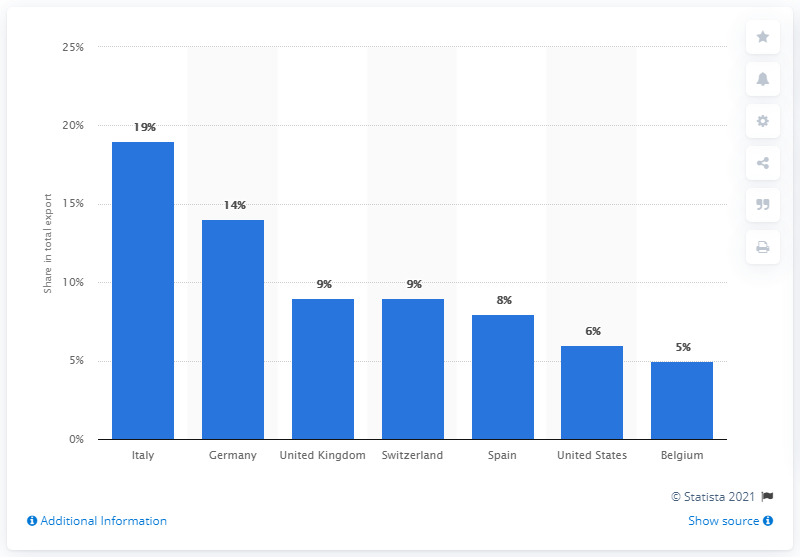Specify some key components in this picture. In 2019, Monaco's most important export partner was Italy. 